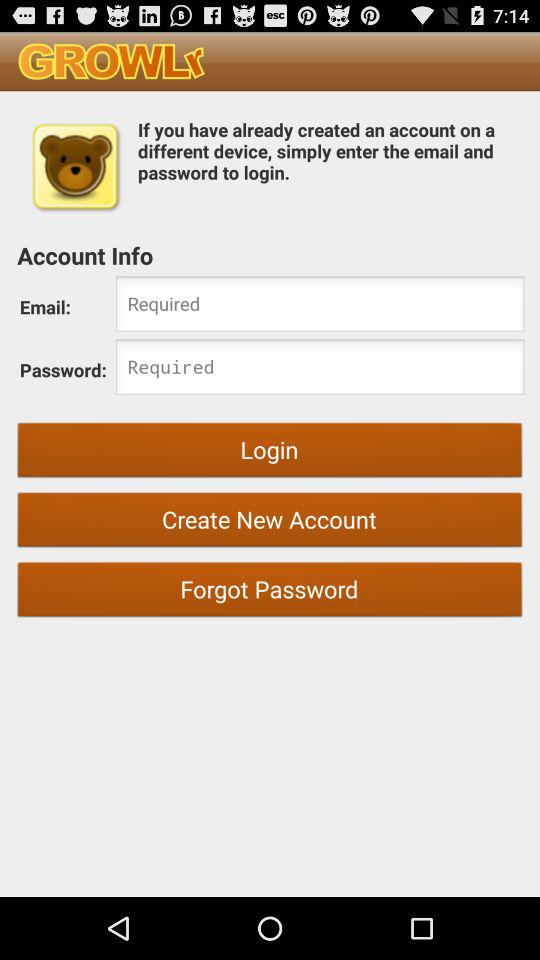What are the requirements to log in? The requirements to log in are an email and a password. 